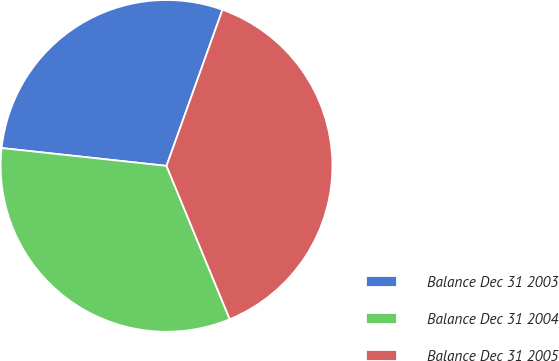Convert chart to OTSL. <chart><loc_0><loc_0><loc_500><loc_500><pie_chart><fcel>Balance Dec 31 2003<fcel>Balance Dec 31 2004<fcel>Balance Dec 31 2005<nl><fcel>28.76%<fcel>32.94%<fcel>38.3%<nl></chart> 